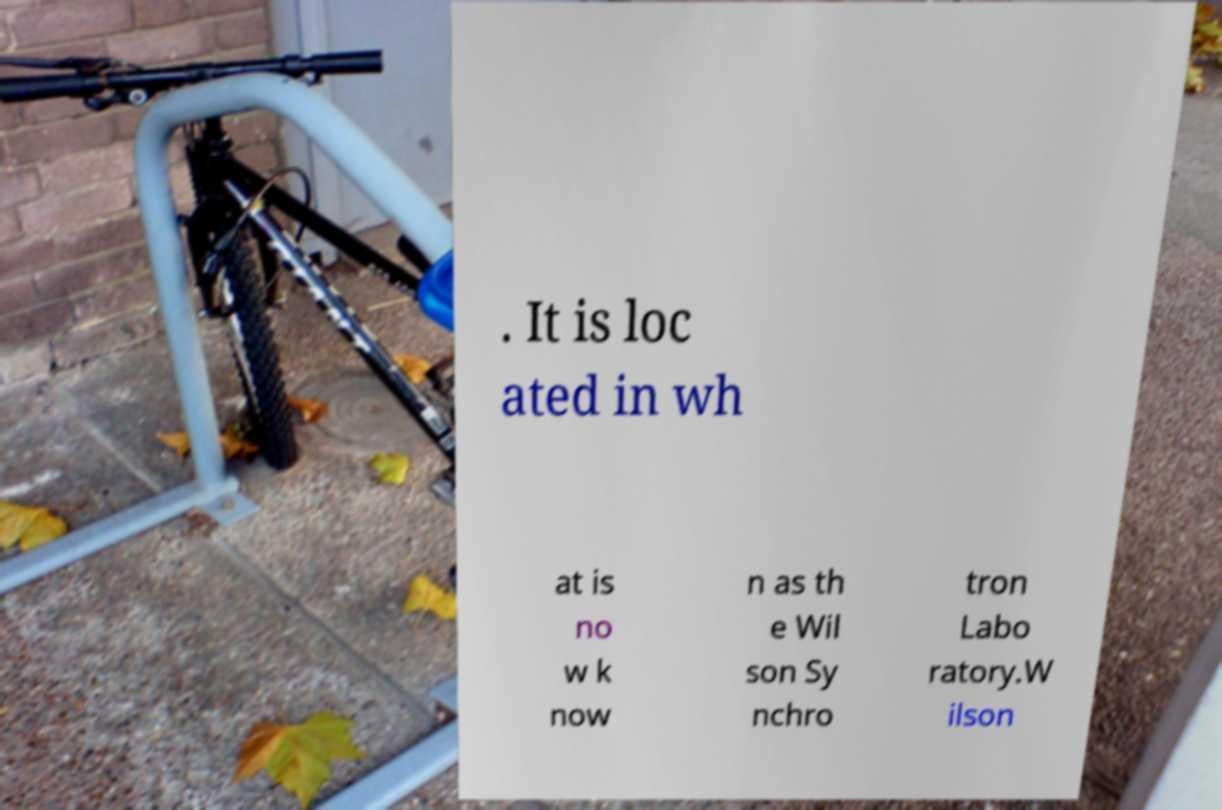What messages or text are displayed in this image? I need them in a readable, typed format. . It is loc ated in wh at is no w k now n as th e Wil son Sy nchro tron Labo ratory.W ilson 